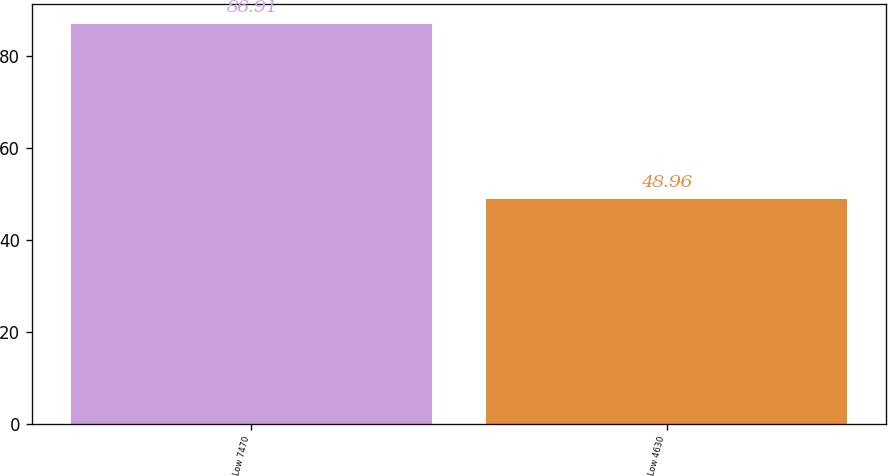Convert chart. <chart><loc_0><loc_0><loc_500><loc_500><bar_chart><fcel>Low 7470<fcel>Low 4630<nl><fcel>86.91<fcel>48.96<nl></chart> 